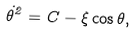<formula> <loc_0><loc_0><loc_500><loc_500>\dot { \theta } ^ { 2 } = C - \xi \cos \theta ,</formula> 